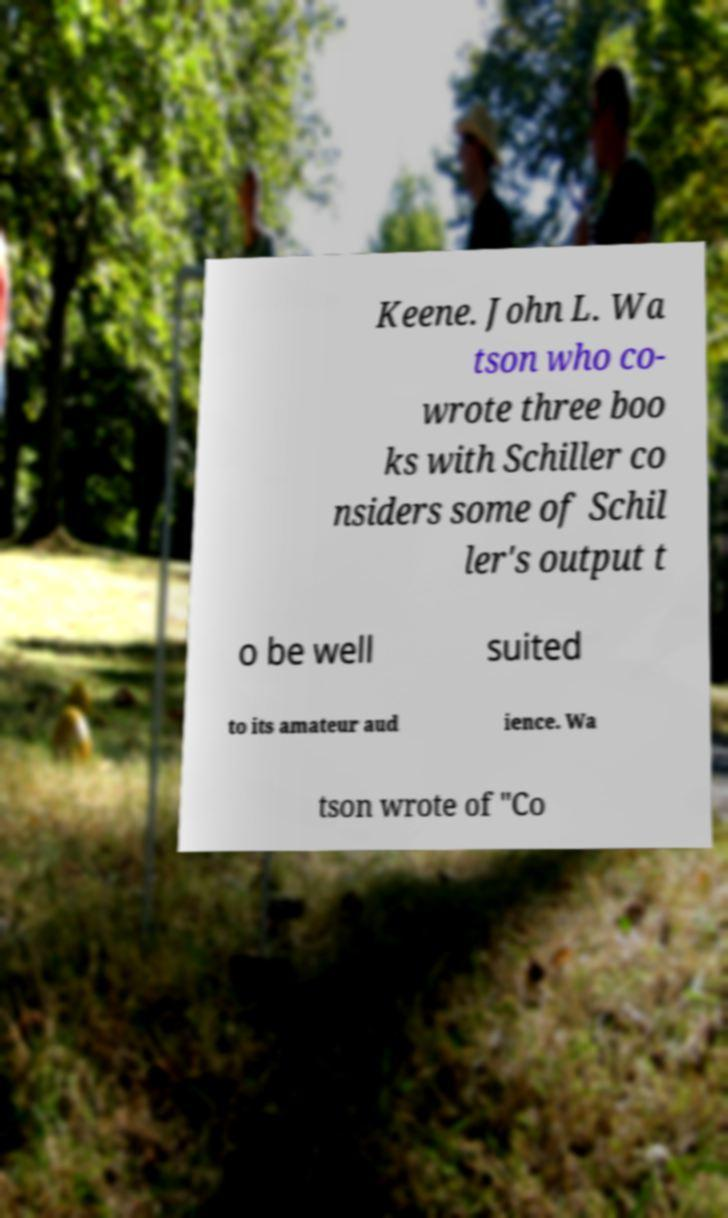Please read and relay the text visible in this image. What does it say? Keene. John L. Wa tson who co- wrote three boo ks with Schiller co nsiders some of Schil ler's output t o be well suited to its amateur aud ience. Wa tson wrote of "Co 